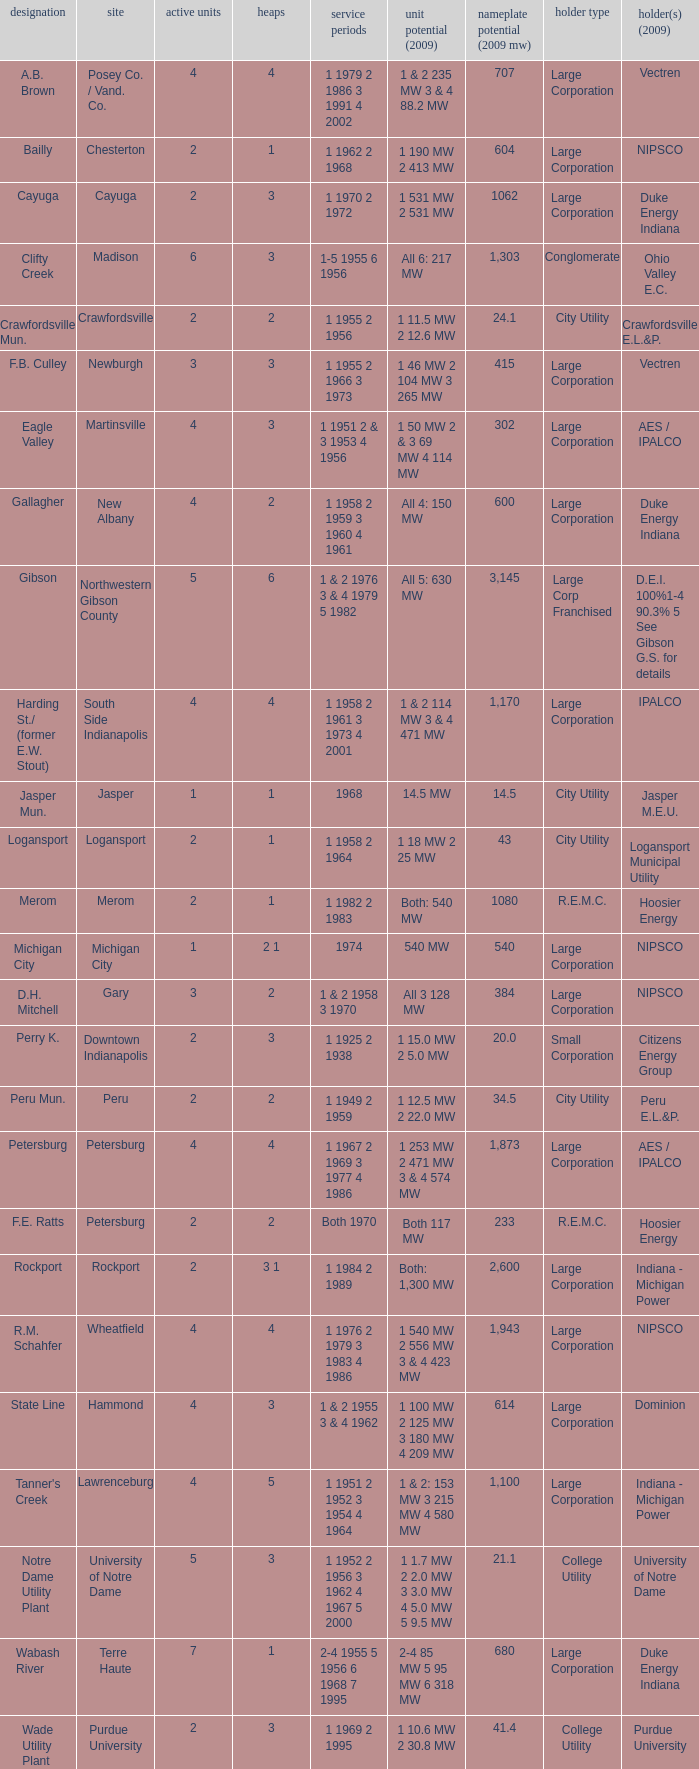Name the number of stacks for 1 & 2 235 mw 3 & 4 88.2 mw 1.0. 